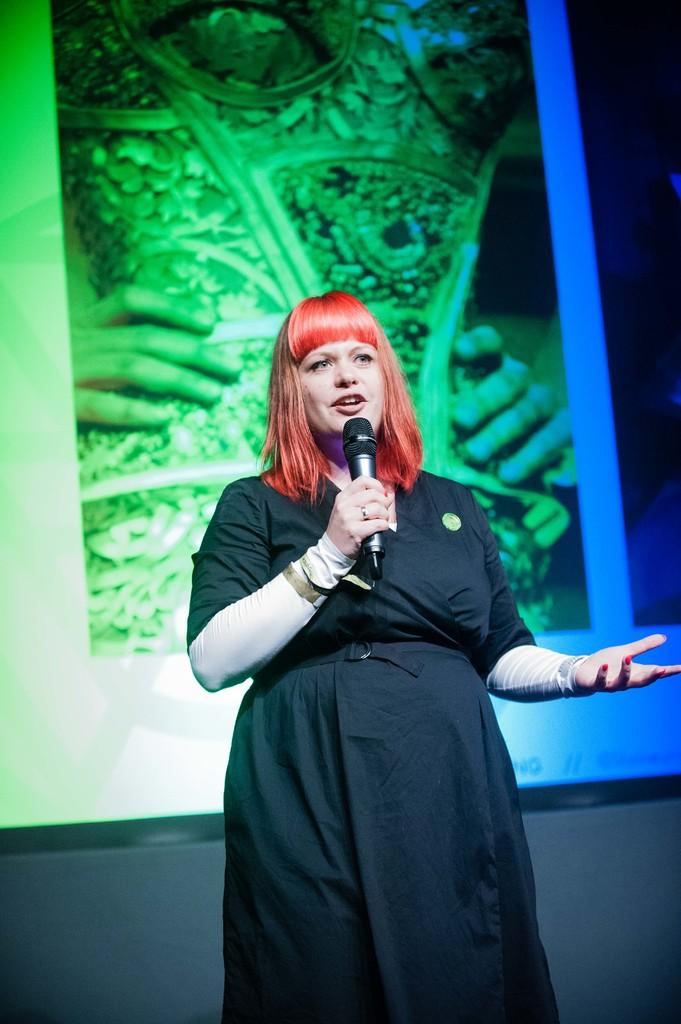Who is the main subject in the image? There is a woman in the image. What is the woman doing in the image? The woman is standing and holding a mic. What can be seen in the background of the image? There is an object that looks like a screen in the background. What type of tax is being discussed on the advertisement in the image? There is no advertisement present in the image, and therefore no discussion of tax can be observed. What color is the bubble floating near the woman in the image? There is no bubble present in the image. 